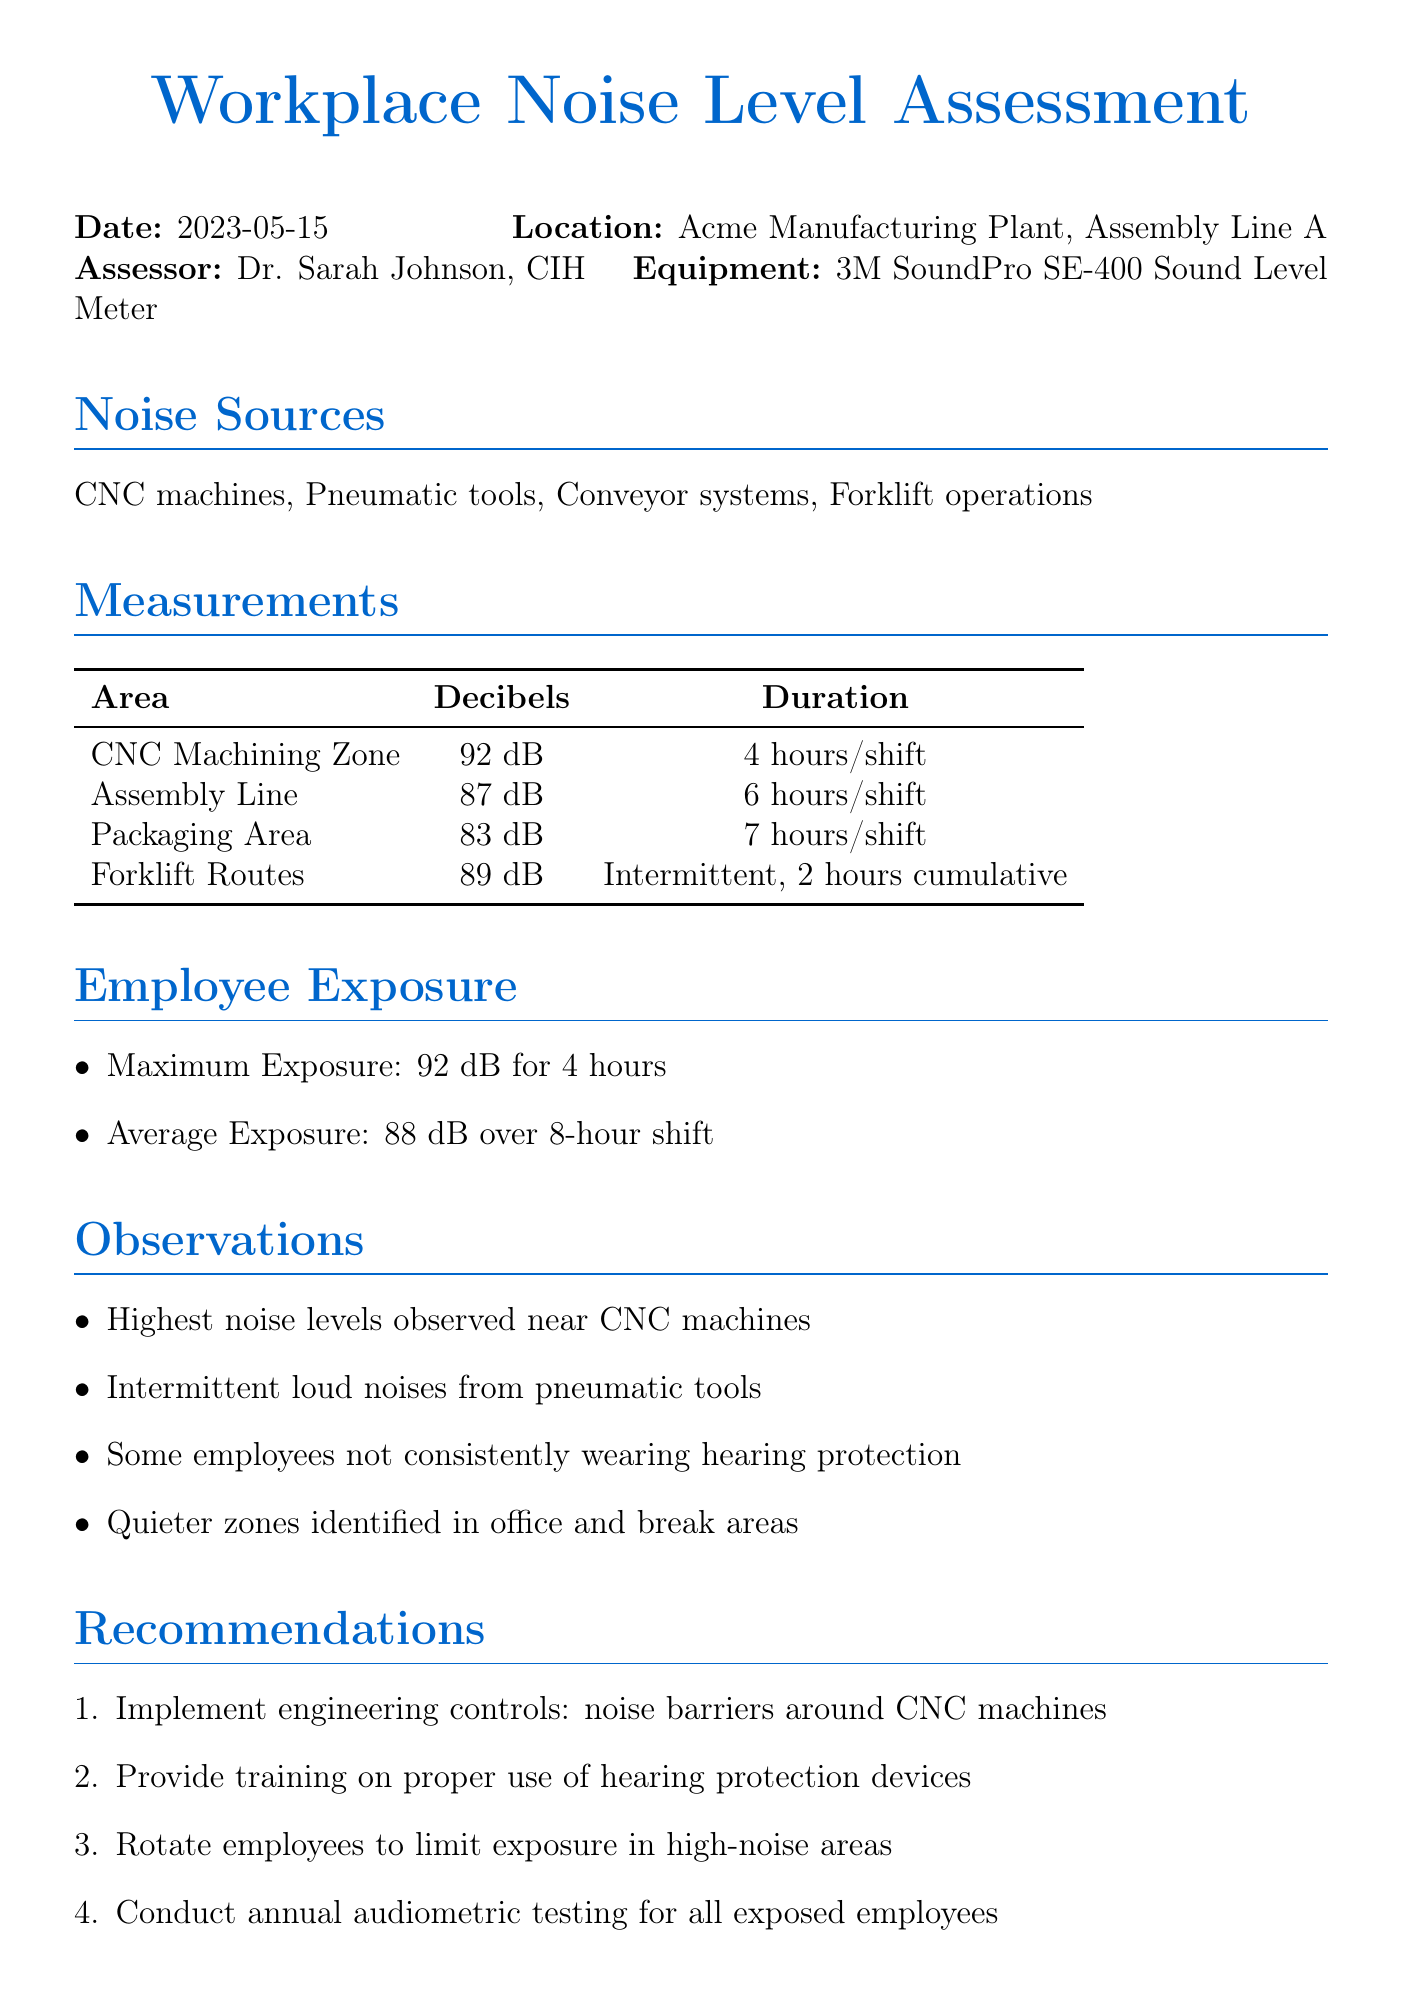What is the date of the assessment? The date of the assessment is clearly stated in the document as the date it was performed.
Answer: 2023-05-15 Who conducted the assessment? The assessor is mentioned in the document as the person who carried out the workplace noise level assessment.
Answer: Dr. Sarah Johnson, CIH What is the maximum exposure level recorded? The document specifies the maximum exposure level for employees observed during the assessment.
Answer: 92 dB for 4 hours What noise source had the highest decibel reading? The measurement section indicates the area with the highest noise levels in decibels.
Answer: CNC Machining Zone What is the action level according to the compliance notes? The compliance section provides details regarding noise action levels, which are required for the hearing conservation program.
Answer: 85 dBA for 8-hour TWA What recommendations are made for employee exposure? The recommendations outline the proposed actions to manage and reduce noise exposure for employees.
Answer: Implement engineering controls: noise barriers around CNC machines How many hours a shift is the average exposure measured? The employee exposure section of the document records the average exposure duration within an 8-hour shift context.
Answer: 88 dB over 8-hour shift Where were quieter zones identified? The observations section mentions specific locations within the workplace that are quieter compared to others.
Answer: office and break areas What equipment was used for the assessment? The document specifies the tool used to measure noise levels during the assessment.
Answer: 3M SoundPro SE-400 Sound Level Meter 